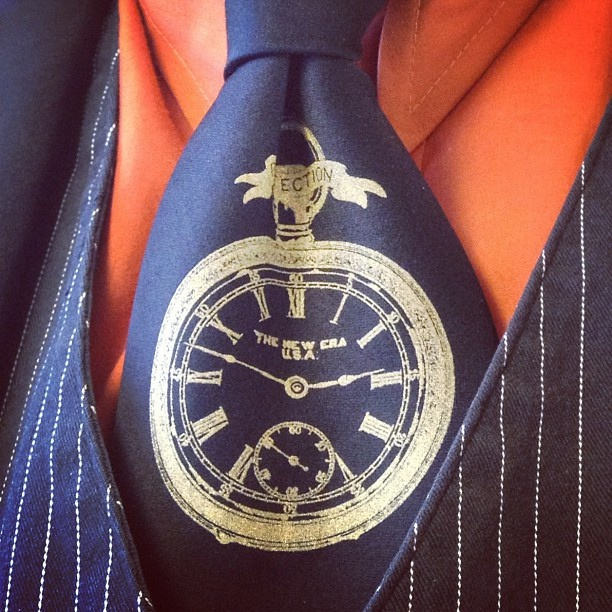Describe the objects in this image and their specific colors. I can see a tie in navy, black, gray, purple, and ivory tones in this image. 